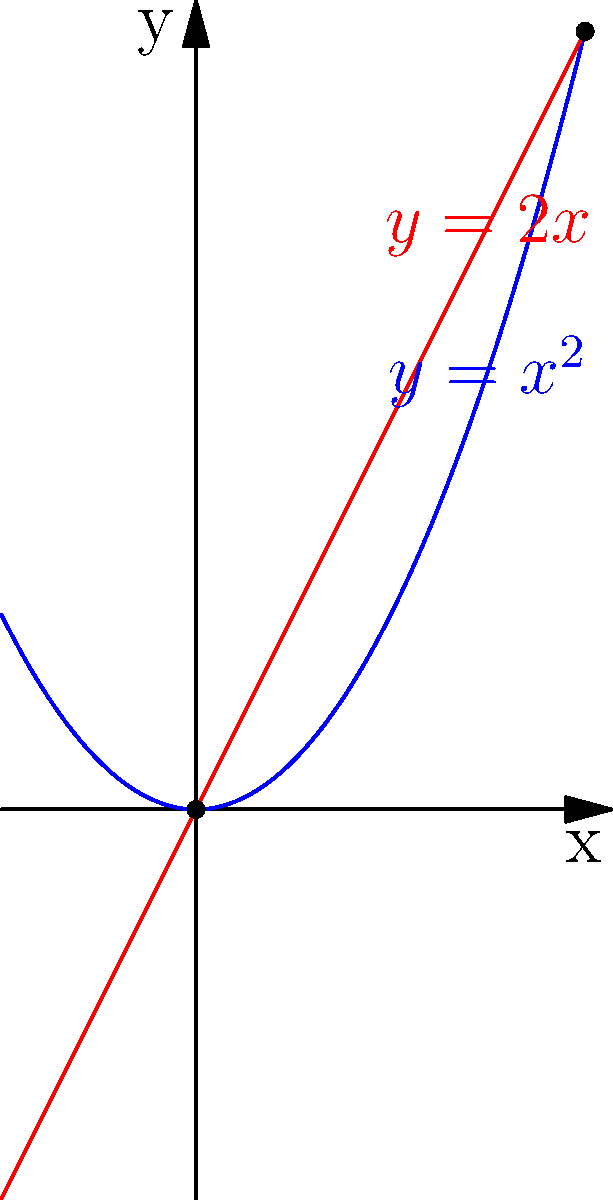Mollie, remember when we used to study math together? Here's a problem that reminds me of those days. The graph shows two intersecting curves: $y=x^2$ (blue) and $y=2x$ (red). What is the area of the region bounded by these two curves? Let's approach this step-by-step, Mollie:

1) First, we need to find the points of intersection. We can do this by setting the equations equal to each other:
   
   $x^2 = 2x$

2) Rearranging the equation:
   
   $x^2 - 2x = 0$
   $x(x - 2) = 0$

3) Solving this, we get $x = 0$ or $x = 2$. So the curves intersect at (0,0) and (2,4).

4) The area we're looking for is the difference between the integral of the upper function and the lower function from x = 0 to x = 2.

5) From 0 to 2, $2x$ is the upper function and $x^2$ is the lower function.

6) So our area A is:

   $A = \int_0^2 (2x - x^2) dx$

7) Integrating:

   $A = [2x^2/2 - x^3/3]_0^2$

8) Evaluating:

   $A = (4 - 8/3) - (0 - 0) = 4 - 8/3 = 4/3$

Therefore, the area of the region is $4/3$ square units.
Answer: $\frac{4}{3}$ square units 